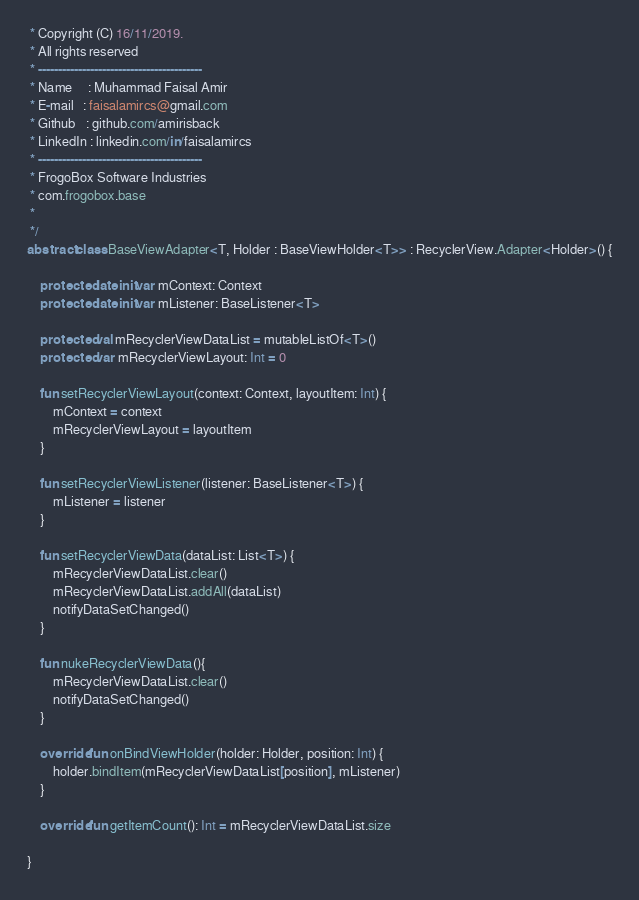<code> <loc_0><loc_0><loc_500><loc_500><_Kotlin_> * Copyright (C) 16/11/2019.
 * All rights reserved
 * -----------------------------------------
 * Name     : Muhammad Faisal Amir
 * E-mail   : faisalamircs@gmail.com
 * Github   : github.com/amirisback
 * LinkedIn : linkedin.com/in/faisalamircs
 * -----------------------------------------
 * FrogoBox Software Industries
 * com.frogobox.base
 *
 */
abstract class BaseViewAdapter<T, Holder : BaseViewHolder<T>> : RecyclerView.Adapter<Holder>() {

    protected lateinit var mContext: Context
    protected lateinit var mListener: BaseListener<T>

    protected val mRecyclerViewDataList = mutableListOf<T>()
    protected var mRecyclerViewLayout: Int = 0

    fun setRecyclerViewLayout(context: Context, layoutItem: Int) {
        mContext = context
        mRecyclerViewLayout = layoutItem
    }

    fun setRecyclerViewListener(listener: BaseListener<T>) {
        mListener = listener
    }

    fun setRecyclerViewData(dataList: List<T>) {
        mRecyclerViewDataList.clear()
        mRecyclerViewDataList.addAll(dataList)
        notifyDataSetChanged()
    }

    fun nukeRecyclerViewData(){
        mRecyclerViewDataList.clear()
        notifyDataSetChanged()
    }

    override fun onBindViewHolder(holder: Holder, position: Int) {
        holder.bindItem(mRecyclerViewDataList[position], mListener)
    }

    override fun getItemCount(): Int = mRecyclerViewDataList.size

}</code> 